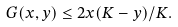Convert formula to latex. <formula><loc_0><loc_0><loc_500><loc_500>G ( x , y ) \leq 2 x ( K - y ) / K .</formula> 